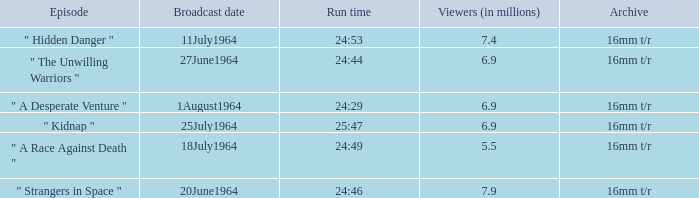What is run time when there were 7.4 million viewers? 24:53. 